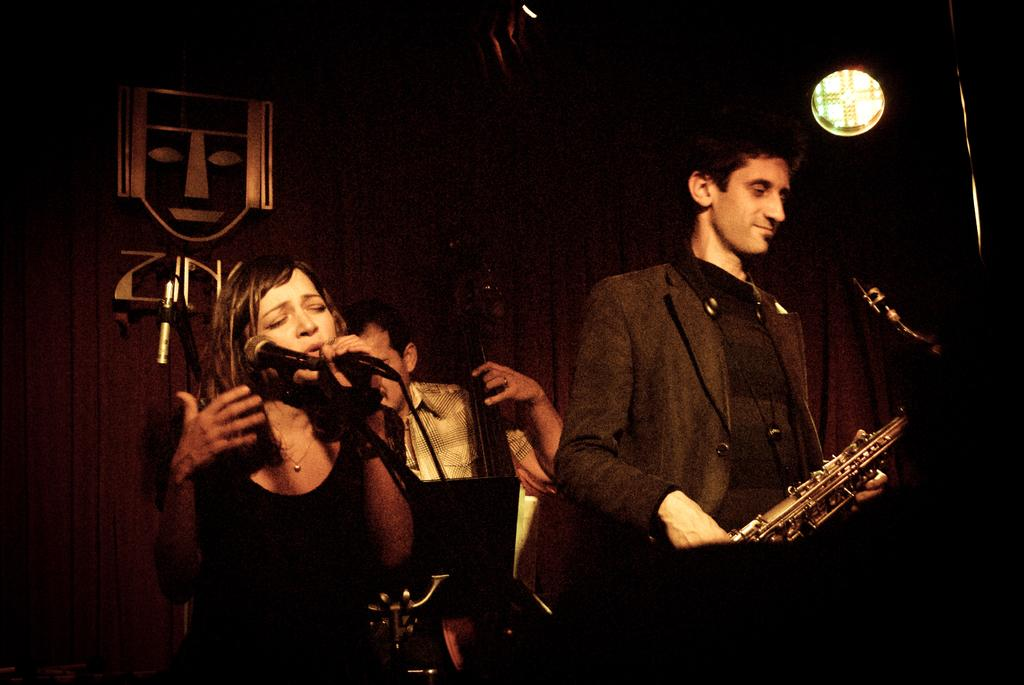What are the persons in the image doing? The persons in the image are standing on the floor and holding musical instruments in their hands. What can be seen in the background of the image? There is a curtain in the background of the image. What type of collar can be seen on the persons in the image? There is no collar visible on the persons in the image. What is the source of the spring in the image? There is no spring present in the image. 